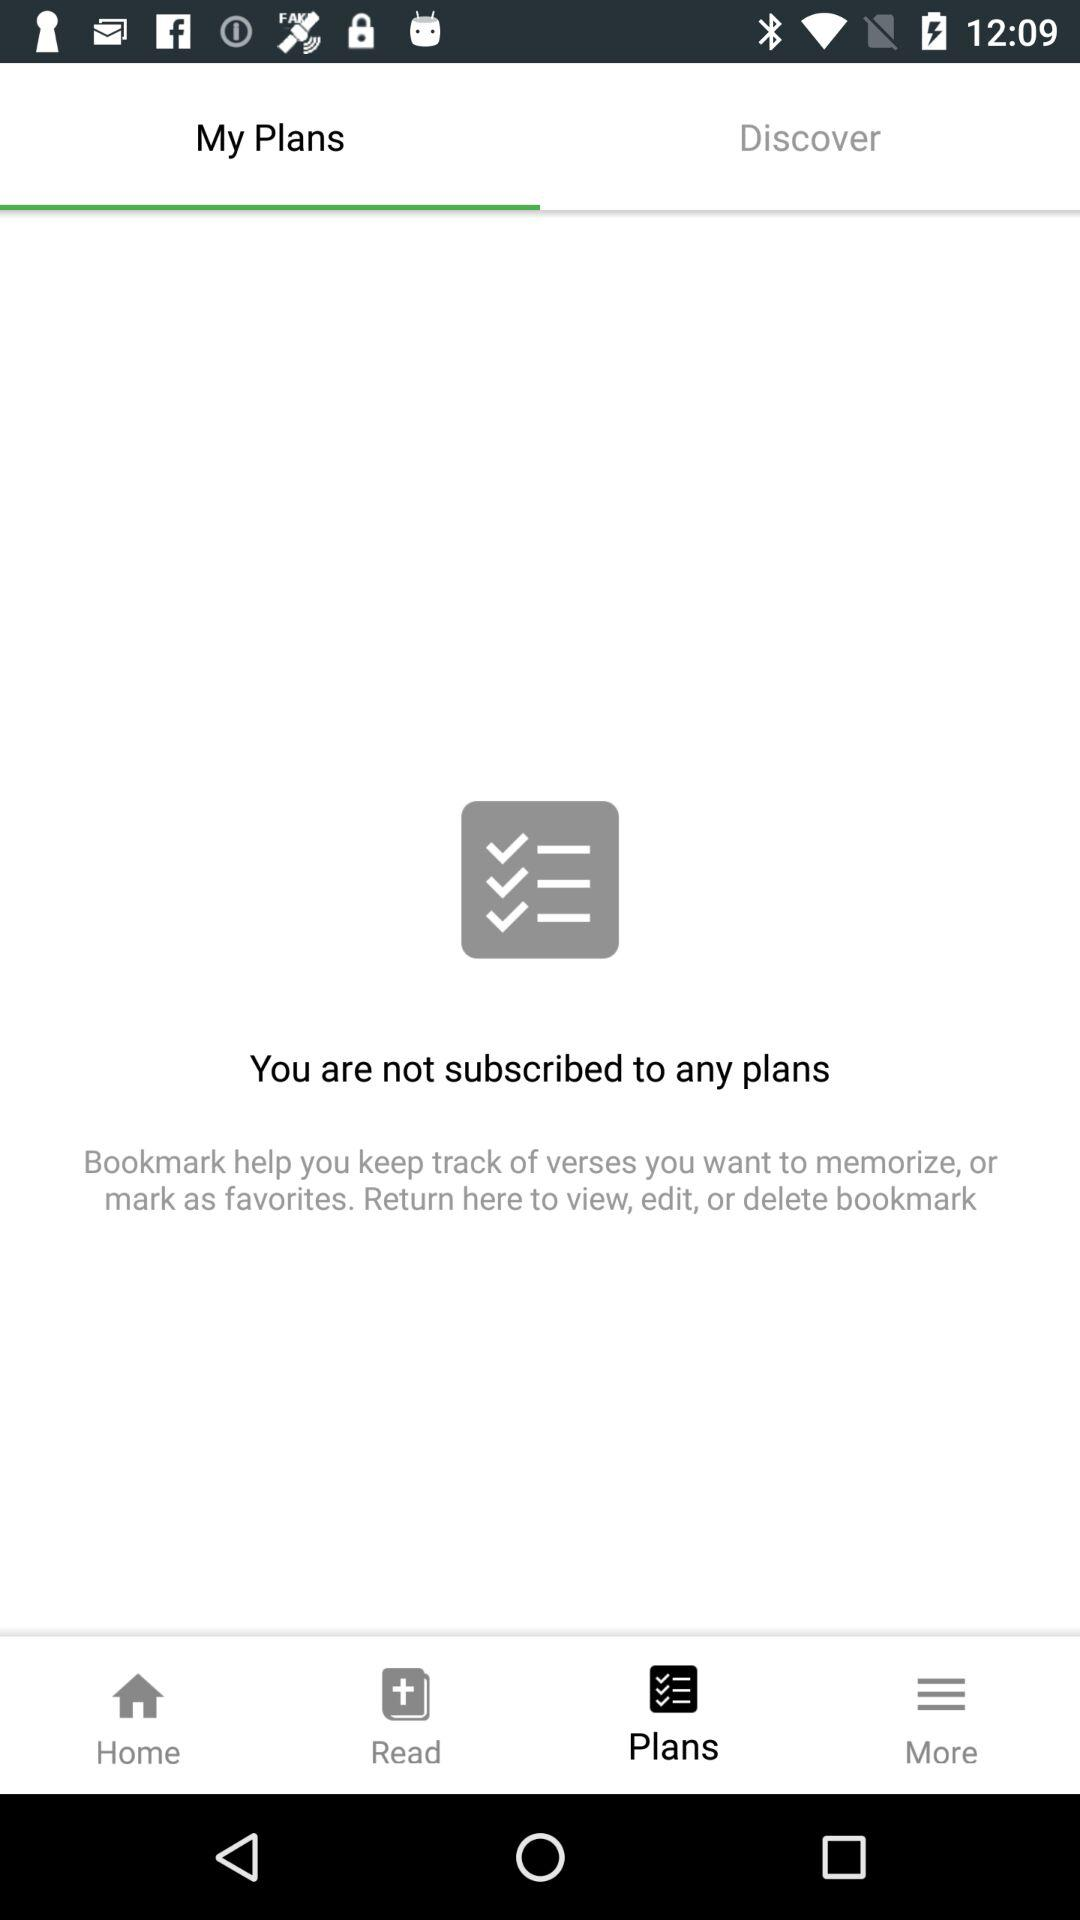How many plans do I have? Based on the image, it appears that you are not subscribed to any plans at the moment. The screen clearly states 'You are not subscribed to any plans' and does not show any listed items, indicating an absence of current plans. 